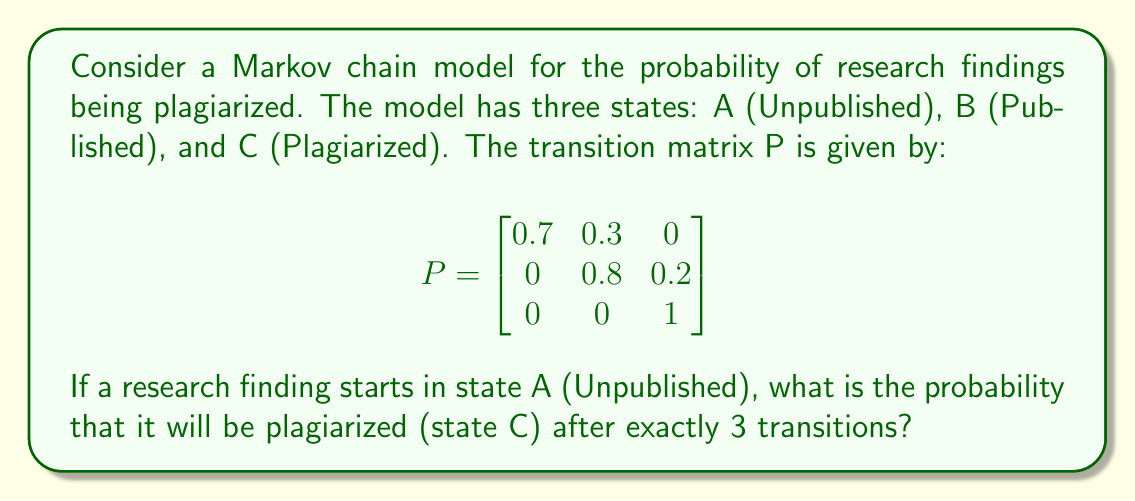Teach me how to tackle this problem. To solve this problem, we need to calculate the 3-step transition probability from state A to state C. We can do this by raising the transition matrix P to the power of 3 and then looking at the element in the first row, third column.

Step 1: Calculate $P^2$
$$P^2 = P \times P = \begin{bmatrix}
0.7 & 0.3 & 0 \\
0 & 0.8 & 0.2 \\
0 & 0 & 1
\end{bmatrix} \times \begin{bmatrix}
0.7 & 0.3 & 0 \\
0 & 0.8 & 0.2 \\
0 & 0 & 1
\end{bmatrix}$$

$$P^2 = \begin{bmatrix}
0.49 & 0.45 & 0.06 \\
0 & 0.64 & 0.36 \\
0 & 0 & 1
\end{bmatrix}$$

Step 2: Calculate $P^3$
$$P^3 = P^2 \times P = \begin{bmatrix}
0.49 & 0.45 & 0.06 \\
0 & 0.64 & 0.36 \\
0 & 0 & 1
\end{bmatrix} \times \begin{bmatrix}
0.7 & 0.3 & 0 \\
0 & 0.8 & 0.2 \\
0 & 0 & 1
\end{bmatrix}$$

$$P^3 = \begin{bmatrix}
0.343 & 0.492 & 0.165 \\
0 & 0.512 & 0.488 \\
0 & 0 & 1
\end{bmatrix}$$

Step 3: Identify the probability of transitioning from state A to state C in 3 steps
The probability we're looking for is the element in the first row, third column of $P^3$, which is 0.165.
Answer: 0.165 